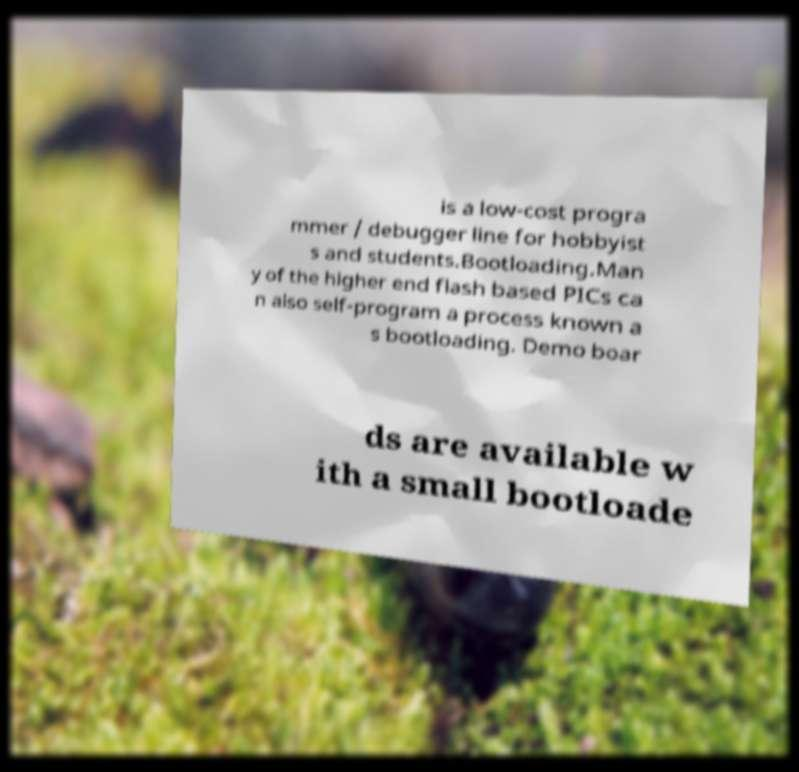I need the written content from this picture converted into text. Can you do that? is a low-cost progra mmer / debugger line for hobbyist s and students.Bootloading.Man y of the higher end flash based PICs ca n also self-program a process known a s bootloading. Demo boar ds are available w ith a small bootloade 